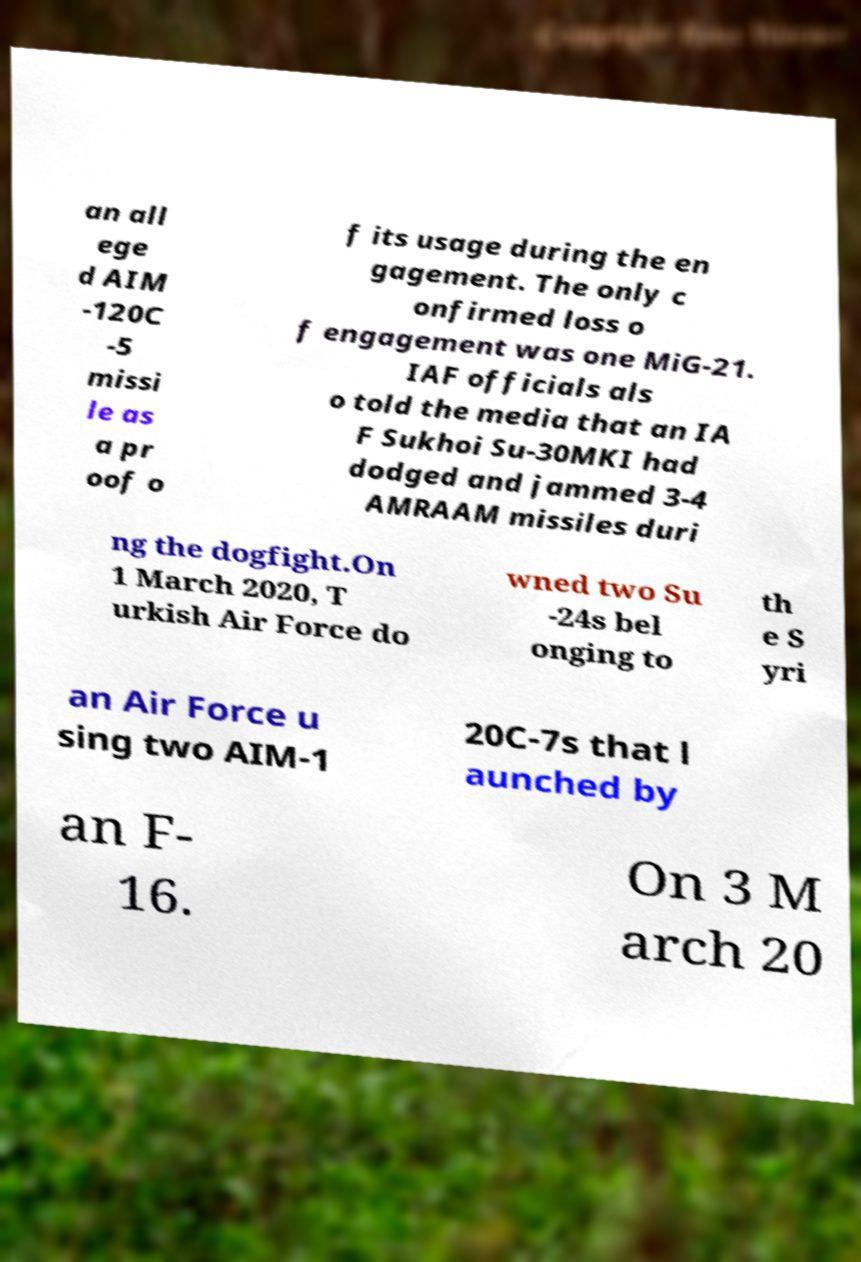Can you accurately transcribe the text from the provided image for me? an all ege d AIM -120C -5 missi le as a pr oof o f its usage during the en gagement. The only c onfirmed loss o f engagement was one MiG-21. IAF officials als o told the media that an IA F Sukhoi Su-30MKI had dodged and jammed 3-4 AMRAAM missiles duri ng the dogfight.On 1 March 2020, T urkish Air Force do wned two Su -24s bel onging to th e S yri an Air Force u sing two AIM-1 20C-7s that l aunched by an F- 16. On 3 M arch 20 